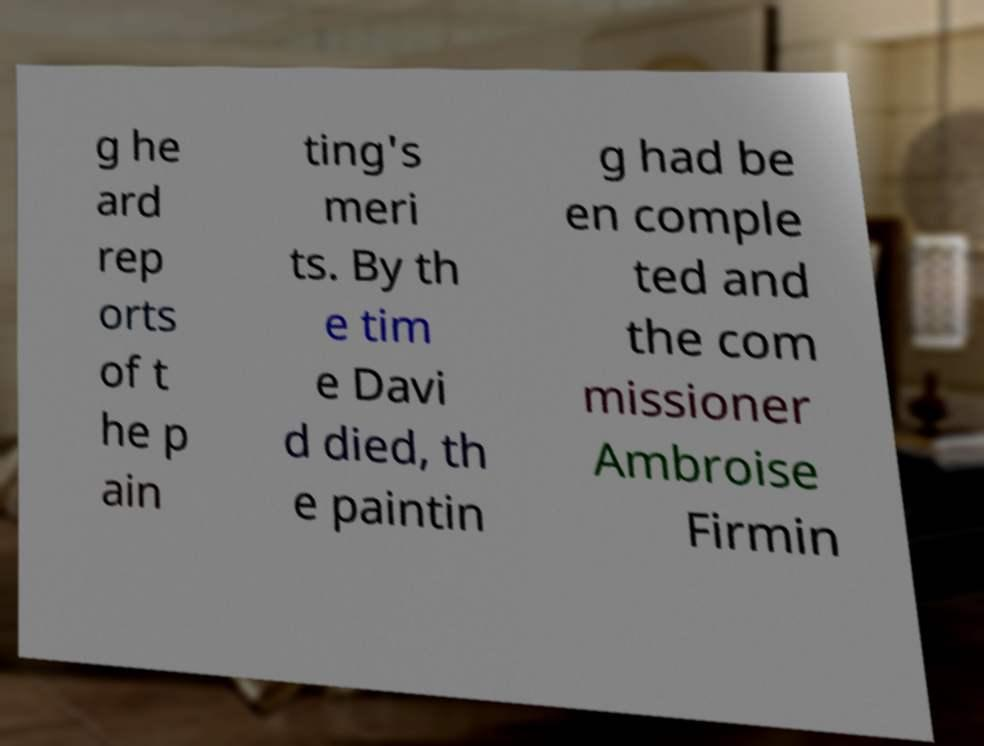What messages or text are displayed in this image? I need them in a readable, typed format. g he ard rep orts of t he p ain ting's meri ts. By th e tim e Davi d died, th e paintin g had be en comple ted and the com missioner Ambroise Firmin 